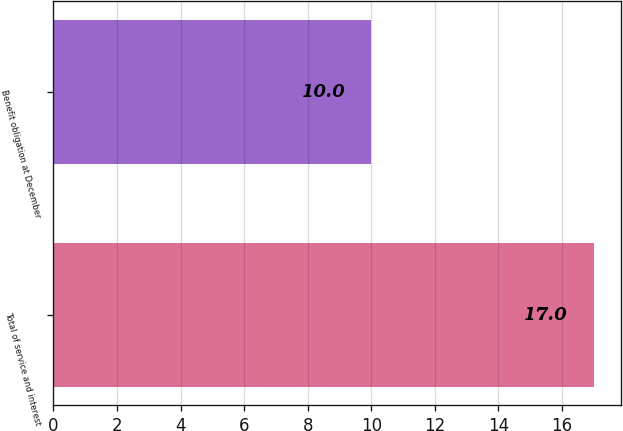Convert chart to OTSL. <chart><loc_0><loc_0><loc_500><loc_500><bar_chart><fcel>Total of service and interest<fcel>Benefit obligation at December<nl><fcel>17<fcel>10<nl></chart> 